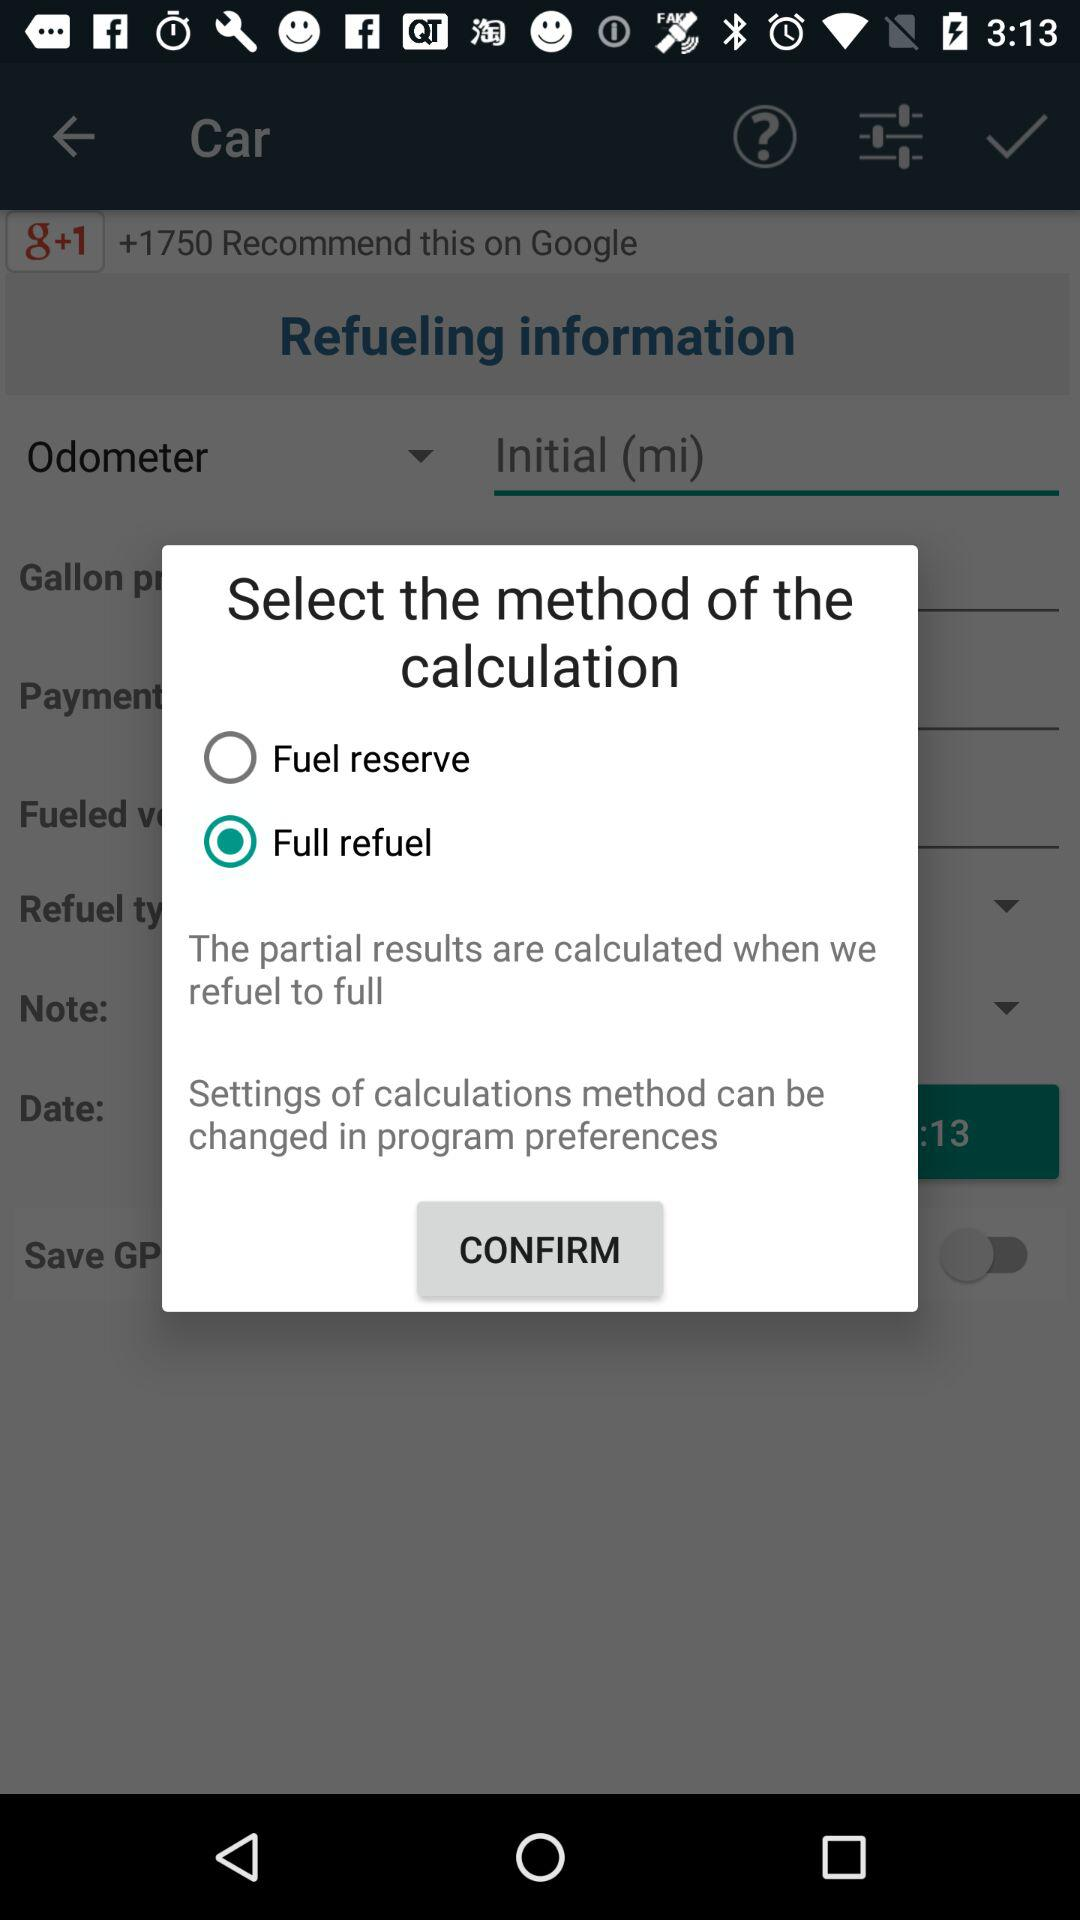Is "Fuel reserve" selected or not selected? "Fuel reserve" is not selected. 